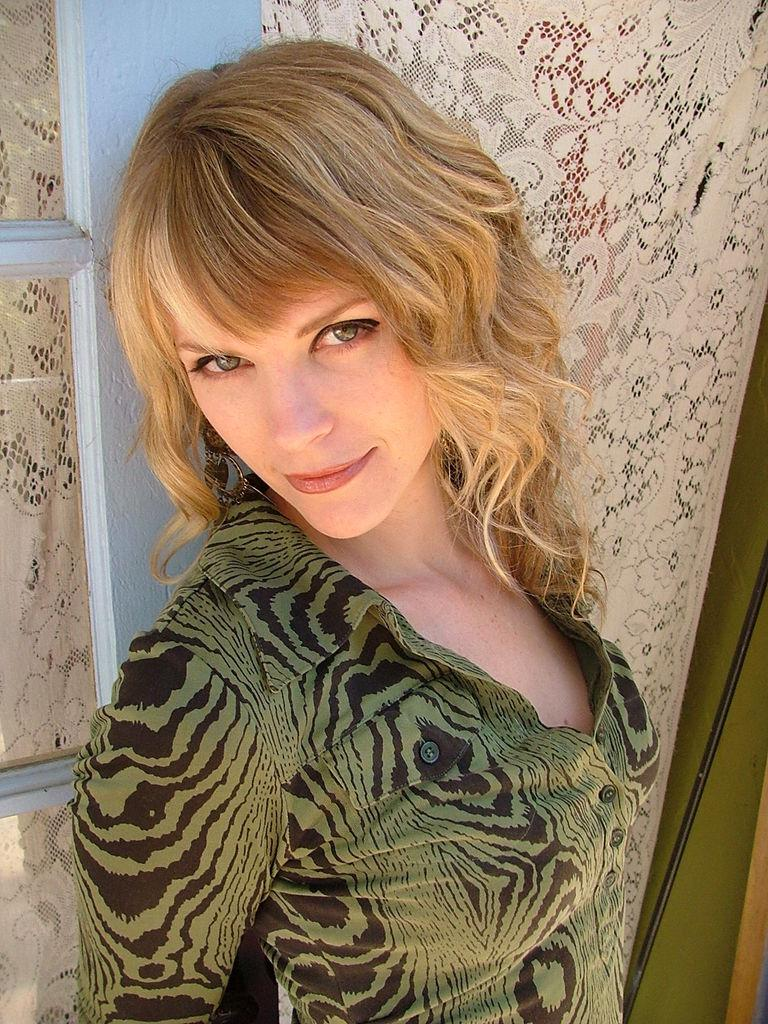What is present in the image? There is a woman in the image. What is the woman's facial expression? The woman is smiling. Can you describe something in the background of the image? There is a cloth in the background of the image. What type of noise can be heard coming from the cart in the image? There is no cart present in the image, so it's not possible to determine what, if any, noise might be heard. 